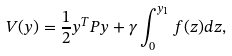Convert formula to latex. <formula><loc_0><loc_0><loc_500><loc_500>V ( y ) = \frac { 1 } { 2 } y ^ { T } P y + \gamma \int _ { 0 } ^ { y _ { 1 } } f ( z ) d z ,</formula> 